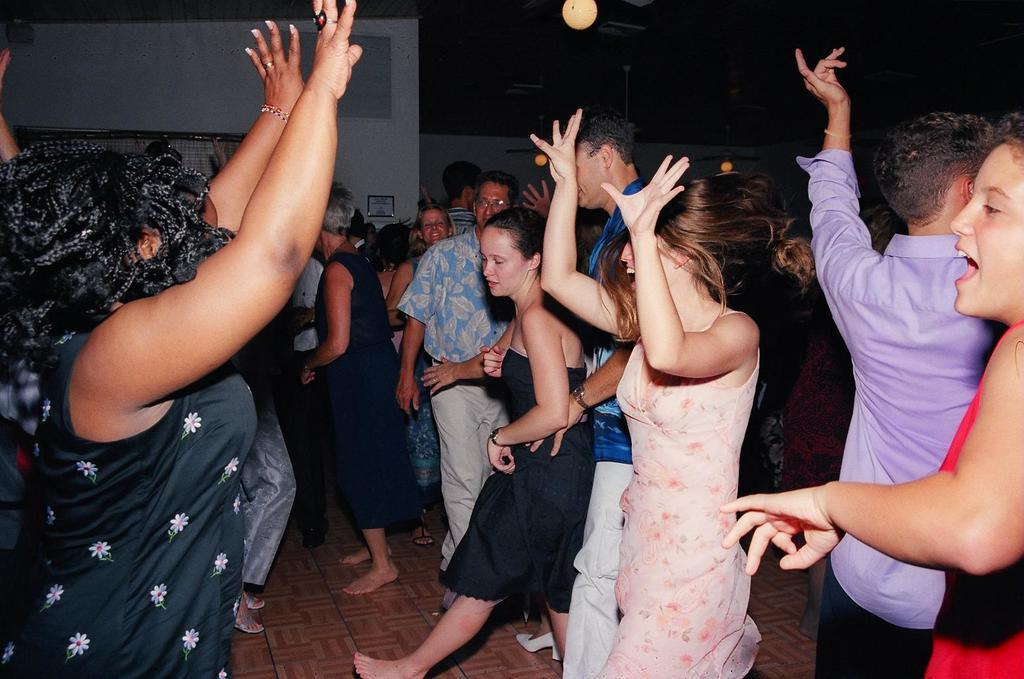How many people are in the image? There is a group of people in the image, but the exact number cannot be determined from the provided facts. What can be seen illuminating the scene in the image? There are lights visible in the image. What type of architectural features are present in the background of the image? There are walls in the background of the image. What else can be seen in the background of the image? There are other objects present in the background of the image, but their specific nature cannot be determined from the provided facts. What type of pail is being used to collect water in the image? There is no pail present in the image, and therefore no such activity can be observed. 